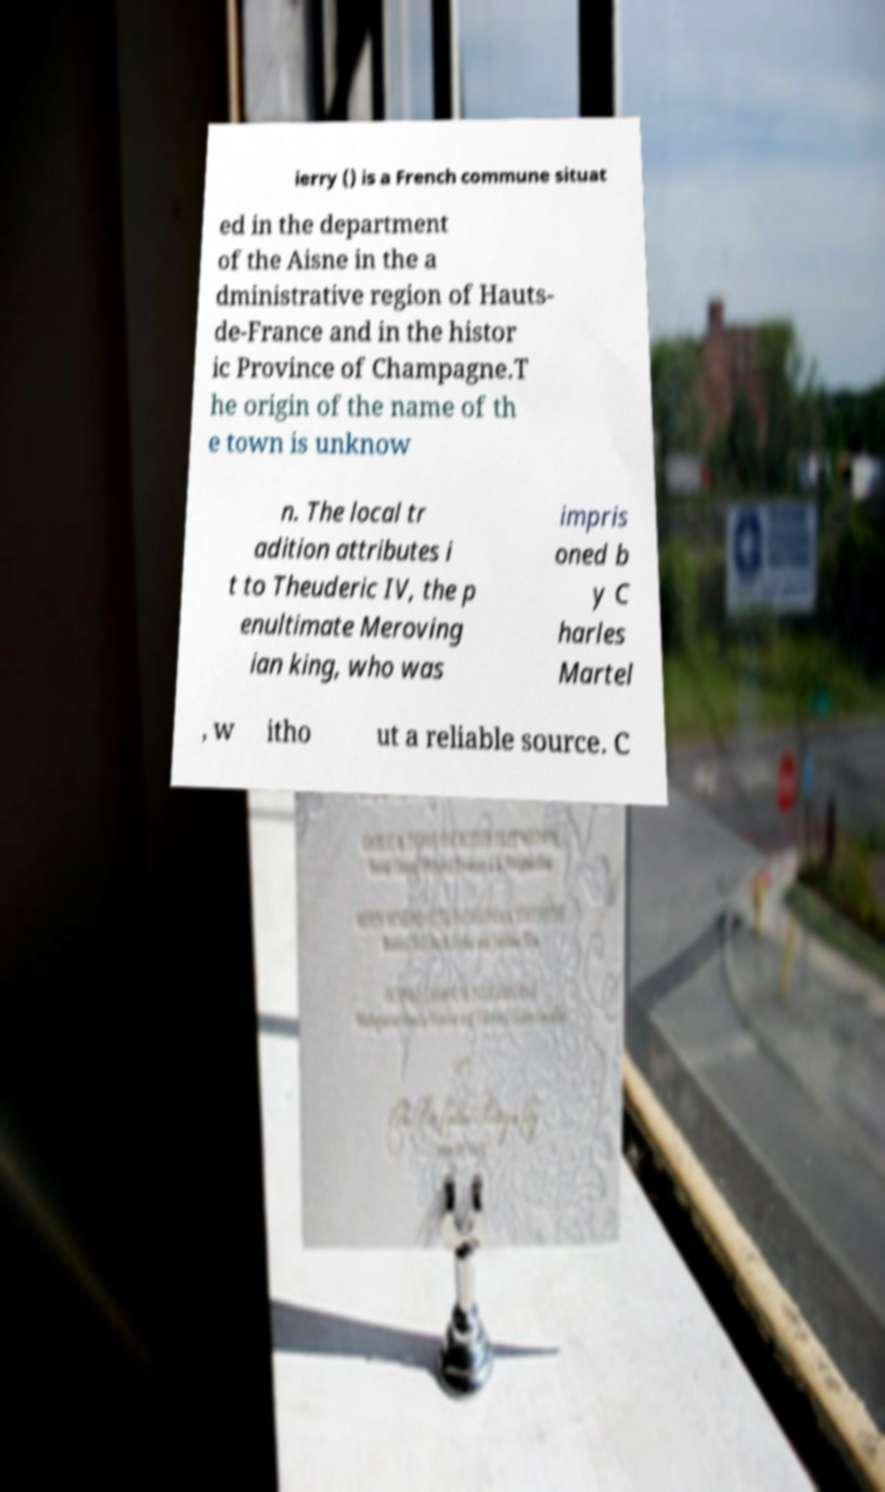There's text embedded in this image that I need extracted. Can you transcribe it verbatim? ierry () is a French commune situat ed in the department of the Aisne in the a dministrative region of Hauts- de-France and in the histor ic Province of Champagne.T he origin of the name of th e town is unknow n. The local tr adition attributes i t to Theuderic IV, the p enultimate Meroving ian king, who was impris oned b y C harles Martel , w itho ut a reliable source. C 